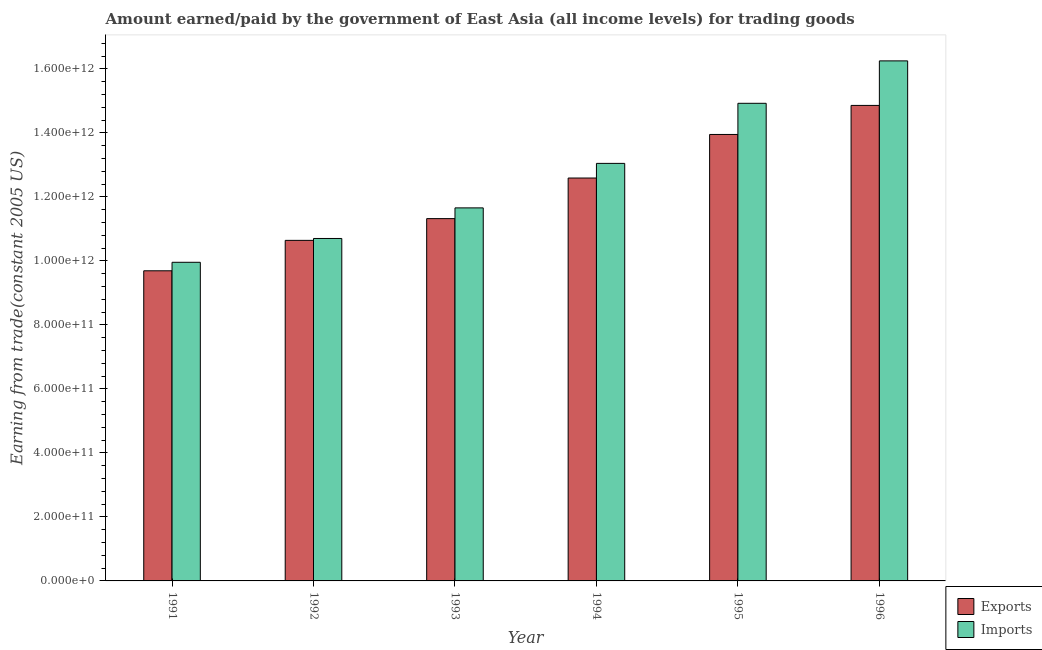How many different coloured bars are there?
Ensure brevity in your answer.  2. How many groups of bars are there?
Offer a terse response. 6. How many bars are there on the 6th tick from the right?
Your response must be concise. 2. What is the label of the 4th group of bars from the left?
Keep it short and to the point. 1994. In how many cases, is the number of bars for a given year not equal to the number of legend labels?
Provide a succinct answer. 0. What is the amount paid for imports in 1991?
Offer a very short reply. 9.96e+11. Across all years, what is the maximum amount earned from exports?
Offer a terse response. 1.49e+12. Across all years, what is the minimum amount paid for imports?
Your answer should be very brief. 9.96e+11. In which year was the amount paid for imports minimum?
Ensure brevity in your answer.  1991. What is the total amount paid for imports in the graph?
Give a very brief answer. 7.65e+12. What is the difference between the amount earned from exports in 1991 and that in 1996?
Your answer should be very brief. -5.17e+11. What is the difference between the amount earned from exports in 1993 and the amount paid for imports in 1995?
Provide a succinct answer. -2.63e+11. What is the average amount earned from exports per year?
Provide a short and direct response. 1.22e+12. In the year 1996, what is the difference between the amount paid for imports and amount earned from exports?
Make the answer very short. 0. What is the ratio of the amount earned from exports in 1992 to that in 1996?
Your answer should be very brief. 0.72. Is the difference between the amount earned from exports in 1994 and 1995 greater than the difference between the amount paid for imports in 1994 and 1995?
Provide a short and direct response. No. What is the difference between the highest and the second highest amount paid for imports?
Your answer should be very brief. 1.33e+11. What is the difference between the highest and the lowest amount paid for imports?
Make the answer very short. 6.29e+11. What does the 2nd bar from the left in 1996 represents?
Your answer should be compact. Imports. What does the 1st bar from the right in 1996 represents?
Keep it short and to the point. Imports. Are all the bars in the graph horizontal?
Provide a short and direct response. No. What is the difference between two consecutive major ticks on the Y-axis?
Offer a very short reply. 2.00e+11. Does the graph contain any zero values?
Your response must be concise. No. How many legend labels are there?
Your answer should be very brief. 2. How are the legend labels stacked?
Ensure brevity in your answer.  Vertical. What is the title of the graph?
Your response must be concise. Amount earned/paid by the government of East Asia (all income levels) for trading goods. Does "Foreign liabilities" appear as one of the legend labels in the graph?
Give a very brief answer. No. What is the label or title of the X-axis?
Keep it short and to the point. Year. What is the label or title of the Y-axis?
Offer a very short reply. Earning from trade(constant 2005 US). What is the Earning from trade(constant 2005 US) in Exports in 1991?
Ensure brevity in your answer.  9.69e+11. What is the Earning from trade(constant 2005 US) in Imports in 1991?
Keep it short and to the point. 9.96e+11. What is the Earning from trade(constant 2005 US) of Exports in 1992?
Make the answer very short. 1.06e+12. What is the Earning from trade(constant 2005 US) in Imports in 1992?
Keep it short and to the point. 1.07e+12. What is the Earning from trade(constant 2005 US) of Exports in 1993?
Provide a succinct answer. 1.13e+12. What is the Earning from trade(constant 2005 US) in Imports in 1993?
Your response must be concise. 1.17e+12. What is the Earning from trade(constant 2005 US) of Exports in 1994?
Offer a terse response. 1.26e+12. What is the Earning from trade(constant 2005 US) of Imports in 1994?
Your response must be concise. 1.30e+12. What is the Earning from trade(constant 2005 US) of Exports in 1995?
Offer a very short reply. 1.40e+12. What is the Earning from trade(constant 2005 US) in Imports in 1995?
Keep it short and to the point. 1.49e+12. What is the Earning from trade(constant 2005 US) in Exports in 1996?
Your response must be concise. 1.49e+12. What is the Earning from trade(constant 2005 US) of Imports in 1996?
Your response must be concise. 1.63e+12. Across all years, what is the maximum Earning from trade(constant 2005 US) in Exports?
Your answer should be very brief. 1.49e+12. Across all years, what is the maximum Earning from trade(constant 2005 US) in Imports?
Your answer should be very brief. 1.63e+12. Across all years, what is the minimum Earning from trade(constant 2005 US) in Exports?
Provide a succinct answer. 9.69e+11. Across all years, what is the minimum Earning from trade(constant 2005 US) of Imports?
Provide a succinct answer. 9.96e+11. What is the total Earning from trade(constant 2005 US) of Exports in the graph?
Your answer should be compact. 7.31e+12. What is the total Earning from trade(constant 2005 US) of Imports in the graph?
Make the answer very short. 7.65e+12. What is the difference between the Earning from trade(constant 2005 US) in Exports in 1991 and that in 1992?
Ensure brevity in your answer.  -9.51e+1. What is the difference between the Earning from trade(constant 2005 US) of Imports in 1991 and that in 1992?
Provide a succinct answer. -7.45e+1. What is the difference between the Earning from trade(constant 2005 US) of Exports in 1991 and that in 1993?
Ensure brevity in your answer.  -1.63e+11. What is the difference between the Earning from trade(constant 2005 US) of Imports in 1991 and that in 1993?
Your response must be concise. -1.70e+11. What is the difference between the Earning from trade(constant 2005 US) in Exports in 1991 and that in 1994?
Provide a short and direct response. -2.90e+11. What is the difference between the Earning from trade(constant 2005 US) in Imports in 1991 and that in 1994?
Keep it short and to the point. -3.09e+11. What is the difference between the Earning from trade(constant 2005 US) in Exports in 1991 and that in 1995?
Make the answer very short. -4.26e+11. What is the difference between the Earning from trade(constant 2005 US) in Imports in 1991 and that in 1995?
Provide a short and direct response. -4.97e+11. What is the difference between the Earning from trade(constant 2005 US) of Exports in 1991 and that in 1996?
Your response must be concise. -5.17e+11. What is the difference between the Earning from trade(constant 2005 US) in Imports in 1991 and that in 1996?
Keep it short and to the point. -6.29e+11. What is the difference between the Earning from trade(constant 2005 US) in Exports in 1992 and that in 1993?
Offer a very short reply. -6.80e+1. What is the difference between the Earning from trade(constant 2005 US) in Imports in 1992 and that in 1993?
Ensure brevity in your answer.  -9.56e+1. What is the difference between the Earning from trade(constant 2005 US) in Exports in 1992 and that in 1994?
Your answer should be very brief. -1.95e+11. What is the difference between the Earning from trade(constant 2005 US) of Imports in 1992 and that in 1994?
Provide a short and direct response. -2.35e+11. What is the difference between the Earning from trade(constant 2005 US) in Exports in 1992 and that in 1995?
Your answer should be compact. -3.31e+11. What is the difference between the Earning from trade(constant 2005 US) of Imports in 1992 and that in 1995?
Your response must be concise. -4.22e+11. What is the difference between the Earning from trade(constant 2005 US) of Exports in 1992 and that in 1996?
Make the answer very short. -4.22e+11. What is the difference between the Earning from trade(constant 2005 US) in Imports in 1992 and that in 1996?
Offer a terse response. -5.55e+11. What is the difference between the Earning from trade(constant 2005 US) in Exports in 1993 and that in 1994?
Offer a very short reply. -1.27e+11. What is the difference between the Earning from trade(constant 2005 US) of Imports in 1993 and that in 1994?
Ensure brevity in your answer.  -1.39e+11. What is the difference between the Earning from trade(constant 2005 US) in Exports in 1993 and that in 1995?
Give a very brief answer. -2.63e+11. What is the difference between the Earning from trade(constant 2005 US) in Imports in 1993 and that in 1995?
Offer a terse response. -3.27e+11. What is the difference between the Earning from trade(constant 2005 US) in Exports in 1993 and that in 1996?
Make the answer very short. -3.54e+11. What is the difference between the Earning from trade(constant 2005 US) of Imports in 1993 and that in 1996?
Give a very brief answer. -4.59e+11. What is the difference between the Earning from trade(constant 2005 US) of Exports in 1994 and that in 1995?
Ensure brevity in your answer.  -1.36e+11. What is the difference between the Earning from trade(constant 2005 US) of Imports in 1994 and that in 1995?
Provide a short and direct response. -1.88e+11. What is the difference between the Earning from trade(constant 2005 US) of Exports in 1994 and that in 1996?
Offer a very short reply. -2.27e+11. What is the difference between the Earning from trade(constant 2005 US) of Imports in 1994 and that in 1996?
Keep it short and to the point. -3.20e+11. What is the difference between the Earning from trade(constant 2005 US) of Exports in 1995 and that in 1996?
Keep it short and to the point. -9.08e+1. What is the difference between the Earning from trade(constant 2005 US) in Imports in 1995 and that in 1996?
Make the answer very short. -1.33e+11. What is the difference between the Earning from trade(constant 2005 US) of Exports in 1991 and the Earning from trade(constant 2005 US) of Imports in 1992?
Keep it short and to the point. -1.01e+11. What is the difference between the Earning from trade(constant 2005 US) of Exports in 1991 and the Earning from trade(constant 2005 US) of Imports in 1993?
Provide a short and direct response. -1.97e+11. What is the difference between the Earning from trade(constant 2005 US) in Exports in 1991 and the Earning from trade(constant 2005 US) in Imports in 1994?
Your answer should be very brief. -3.36e+11. What is the difference between the Earning from trade(constant 2005 US) of Exports in 1991 and the Earning from trade(constant 2005 US) of Imports in 1995?
Your answer should be very brief. -5.23e+11. What is the difference between the Earning from trade(constant 2005 US) in Exports in 1991 and the Earning from trade(constant 2005 US) in Imports in 1996?
Give a very brief answer. -6.56e+11. What is the difference between the Earning from trade(constant 2005 US) of Exports in 1992 and the Earning from trade(constant 2005 US) of Imports in 1993?
Ensure brevity in your answer.  -1.02e+11. What is the difference between the Earning from trade(constant 2005 US) of Exports in 1992 and the Earning from trade(constant 2005 US) of Imports in 1994?
Make the answer very short. -2.41e+11. What is the difference between the Earning from trade(constant 2005 US) in Exports in 1992 and the Earning from trade(constant 2005 US) in Imports in 1995?
Make the answer very short. -4.28e+11. What is the difference between the Earning from trade(constant 2005 US) of Exports in 1992 and the Earning from trade(constant 2005 US) of Imports in 1996?
Keep it short and to the point. -5.61e+11. What is the difference between the Earning from trade(constant 2005 US) in Exports in 1993 and the Earning from trade(constant 2005 US) in Imports in 1994?
Keep it short and to the point. -1.73e+11. What is the difference between the Earning from trade(constant 2005 US) of Exports in 1993 and the Earning from trade(constant 2005 US) of Imports in 1995?
Your answer should be compact. -3.60e+11. What is the difference between the Earning from trade(constant 2005 US) of Exports in 1993 and the Earning from trade(constant 2005 US) of Imports in 1996?
Offer a terse response. -4.93e+11. What is the difference between the Earning from trade(constant 2005 US) of Exports in 1994 and the Earning from trade(constant 2005 US) of Imports in 1995?
Ensure brevity in your answer.  -2.33e+11. What is the difference between the Earning from trade(constant 2005 US) in Exports in 1994 and the Earning from trade(constant 2005 US) in Imports in 1996?
Give a very brief answer. -3.66e+11. What is the difference between the Earning from trade(constant 2005 US) of Exports in 1995 and the Earning from trade(constant 2005 US) of Imports in 1996?
Your answer should be very brief. -2.30e+11. What is the average Earning from trade(constant 2005 US) in Exports per year?
Make the answer very short. 1.22e+12. What is the average Earning from trade(constant 2005 US) of Imports per year?
Offer a very short reply. 1.28e+12. In the year 1991, what is the difference between the Earning from trade(constant 2005 US) of Exports and Earning from trade(constant 2005 US) of Imports?
Your response must be concise. -2.66e+1. In the year 1992, what is the difference between the Earning from trade(constant 2005 US) in Exports and Earning from trade(constant 2005 US) in Imports?
Offer a very short reply. -5.95e+09. In the year 1993, what is the difference between the Earning from trade(constant 2005 US) in Exports and Earning from trade(constant 2005 US) in Imports?
Your answer should be very brief. -3.36e+1. In the year 1994, what is the difference between the Earning from trade(constant 2005 US) in Exports and Earning from trade(constant 2005 US) in Imports?
Ensure brevity in your answer.  -4.57e+1. In the year 1995, what is the difference between the Earning from trade(constant 2005 US) in Exports and Earning from trade(constant 2005 US) in Imports?
Make the answer very short. -9.74e+1. In the year 1996, what is the difference between the Earning from trade(constant 2005 US) of Exports and Earning from trade(constant 2005 US) of Imports?
Offer a terse response. -1.39e+11. What is the ratio of the Earning from trade(constant 2005 US) in Exports in 1991 to that in 1992?
Your answer should be compact. 0.91. What is the ratio of the Earning from trade(constant 2005 US) of Imports in 1991 to that in 1992?
Your answer should be compact. 0.93. What is the ratio of the Earning from trade(constant 2005 US) of Exports in 1991 to that in 1993?
Your answer should be very brief. 0.86. What is the ratio of the Earning from trade(constant 2005 US) in Imports in 1991 to that in 1993?
Keep it short and to the point. 0.85. What is the ratio of the Earning from trade(constant 2005 US) in Exports in 1991 to that in 1994?
Your response must be concise. 0.77. What is the ratio of the Earning from trade(constant 2005 US) in Imports in 1991 to that in 1994?
Your response must be concise. 0.76. What is the ratio of the Earning from trade(constant 2005 US) in Exports in 1991 to that in 1995?
Provide a short and direct response. 0.69. What is the ratio of the Earning from trade(constant 2005 US) of Imports in 1991 to that in 1995?
Provide a short and direct response. 0.67. What is the ratio of the Earning from trade(constant 2005 US) of Exports in 1991 to that in 1996?
Keep it short and to the point. 0.65. What is the ratio of the Earning from trade(constant 2005 US) of Imports in 1991 to that in 1996?
Provide a short and direct response. 0.61. What is the ratio of the Earning from trade(constant 2005 US) of Exports in 1992 to that in 1993?
Your answer should be compact. 0.94. What is the ratio of the Earning from trade(constant 2005 US) of Imports in 1992 to that in 1993?
Ensure brevity in your answer.  0.92. What is the ratio of the Earning from trade(constant 2005 US) of Exports in 1992 to that in 1994?
Provide a short and direct response. 0.85. What is the ratio of the Earning from trade(constant 2005 US) in Imports in 1992 to that in 1994?
Offer a very short reply. 0.82. What is the ratio of the Earning from trade(constant 2005 US) in Exports in 1992 to that in 1995?
Make the answer very short. 0.76. What is the ratio of the Earning from trade(constant 2005 US) in Imports in 1992 to that in 1995?
Keep it short and to the point. 0.72. What is the ratio of the Earning from trade(constant 2005 US) of Exports in 1992 to that in 1996?
Give a very brief answer. 0.72. What is the ratio of the Earning from trade(constant 2005 US) in Imports in 1992 to that in 1996?
Your answer should be very brief. 0.66. What is the ratio of the Earning from trade(constant 2005 US) in Exports in 1993 to that in 1994?
Your answer should be compact. 0.9. What is the ratio of the Earning from trade(constant 2005 US) in Imports in 1993 to that in 1994?
Provide a succinct answer. 0.89. What is the ratio of the Earning from trade(constant 2005 US) in Exports in 1993 to that in 1995?
Make the answer very short. 0.81. What is the ratio of the Earning from trade(constant 2005 US) of Imports in 1993 to that in 1995?
Your answer should be very brief. 0.78. What is the ratio of the Earning from trade(constant 2005 US) in Exports in 1993 to that in 1996?
Offer a very short reply. 0.76. What is the ratio of the Earning from trade(constant 2005 US) in Imports in 1993 to that in 1996?
Provide a succinct answer. 0.72. What is the ratio of the Earning from trade(constant 2005 US) in Exports in 1994 to that in 1995?
Your answer should be very brief. 0.9. What is the ratio of the Earning from trade(constant 2005 US) of Imports in 1994 to that in 1995?
Your response must be concise. 0.87. What is the ratio of the Earning from trade(constant 2005 US) of Exports in 1994 to that in 1996?
Your answer should be compact. 0.85. What is the ratio of the Earning from trade(constant 2005 US) of Imports in 1994 to that in 1996?
Provide a short and direct response. 0.8. What is the ratio of the Earning from trade(constant 2005 US) of Exports in 1995 to that in 1996?
Provide a succinct answer. 0.94. What is the ratio of the Earning from trade(constant 2005 US) in Imports in 1995 to that in 1996?
Make the answer very short. 0.92. What is the difference between the highest and the second highest Earning from trade(constant 2005 US) of Exports?
Keep it short and to the point. 9.08e+1. What is the difference between the highest and the second highest Earning from trade(constant 2005 US) in Imports?
Provide a short and direct response. 1.33e+11. What is the difference between the highest and the lowest Earning from trade(constant 2005 US) of Exports?
Keep it short and to the point. 5.17e+11. What is the difference between the highest and the lowest Earning from trade(constant 2005 US) of Imports?
Your answer should be compact. 6.29e+11. 